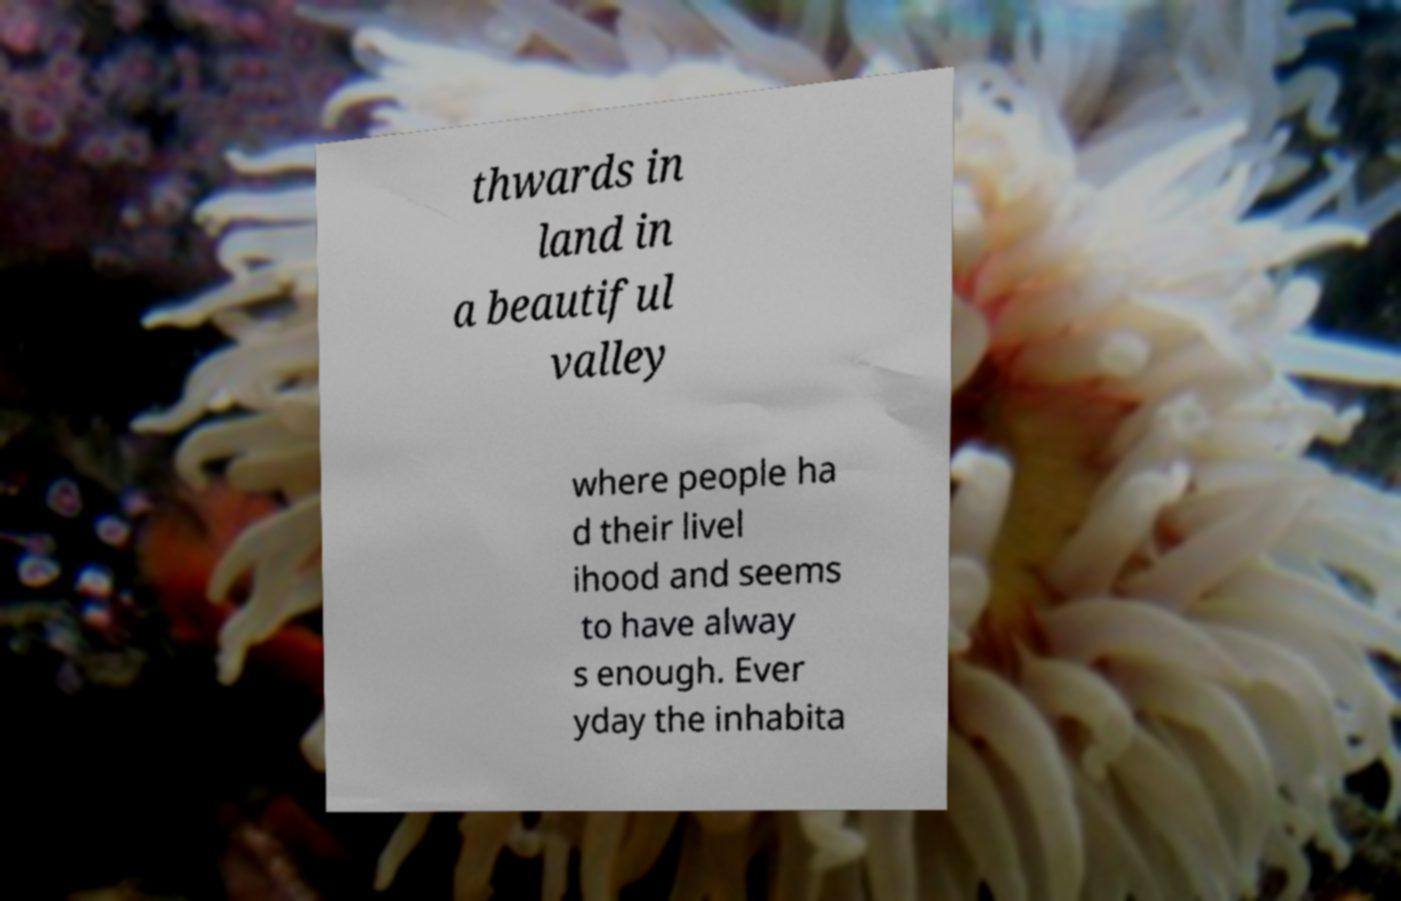Please identify and transcribe the text found in this image. thwards in land in a beautiful valley where people ha d their livel ihood and seems to have alway s enough. Ever yday the inhabita 